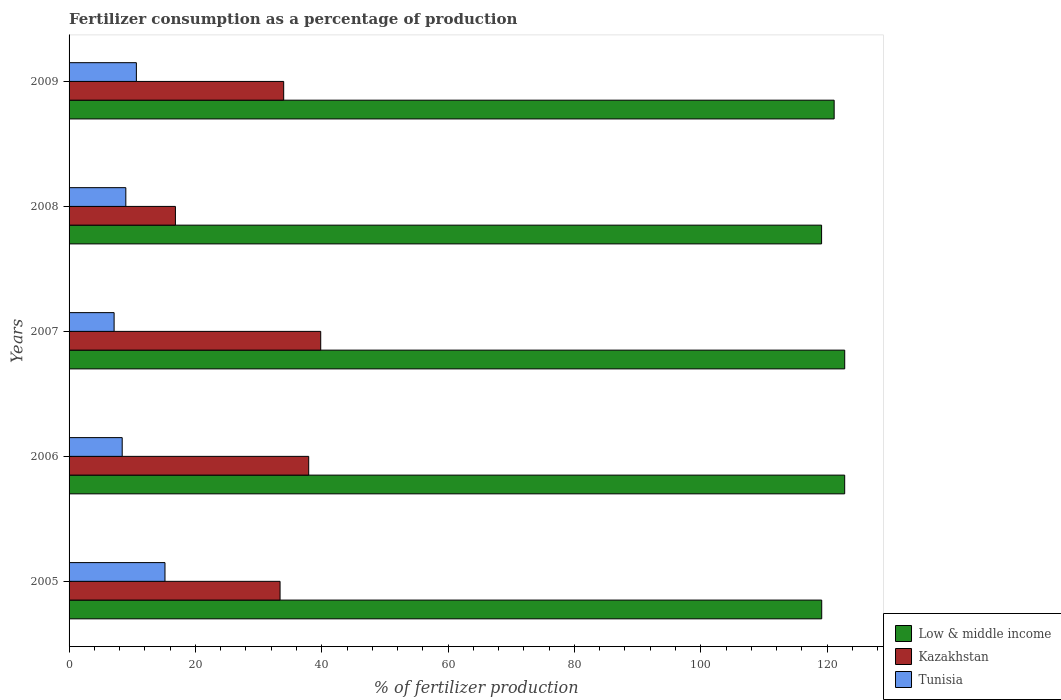How many groups of bars are there?
Provide a succinct answer. 5. Are the number of bars per tick equal to the number of legend labels?
Provide a short and direct response. Yes. Are the number of bars on each tick of the Y-axis equal?
Offer a terse response. Yes. What is the percentage of fertilizers consumed in Low & middle income in 2006?
Provide a short and direct response. 122.79. Across all years, what is the maximum percentage of fertilizers consumed in Tunisia?
Ensure brevity in your answer.  15.18. Across all years, what is the minimum percentage of fertilizers consumed in Kazakhstan?
Give a very brief answer. 16.84. In which year was the percentage of fertilizers consumed in Kazakhstan maximum?
Ensure brevity in your answer.  2007. What is the total percentage of fertilizers consumed in Low & middle income in the graph?
Your answer should be very brief. 604.98. What is the difference between the percentage of fertilizers consumed in Low & middle income in 2007 and that in 2009?
Provide a short and direct response. 1.67. What is the difference between the percentage of fertilizers consumed in Kazakhstan in 2006 and the percentage of fertilizers consumed in Low & middle income in 2009?
Offer a very short reply. -83.18. What is the average percentage of fertilizers consumed in Kazakhstan per year?
Give a very brief answer. 32.4. In the year 2007, what is the difference between the percentage of fertilizers consumed in Kazakhstan and percentage of fertilizers consumed in Low & middle income?
Keep it short and to the point. -82.95. What is the ratio of the percentage of fertilizers consumed in Tunisia in 2006 to that in 2008?
Give a very brief answer. 0.94. Is the percentage of fertilizers consumed in Low & middle income in 2005 less than that in 2008?
Your answer should be compact. No. Is the difference between the percentage of fertilizers consumed in Kazakhstan in 2005 and 2008 greater than the difference between the percentage of fertilizers consumed in Low & middle income in 2005 and 2008?
Offer a very short reply. Yes. What is the difference between the highest and the second highest percentage of fertilizers consumed in Kazakhstan?
Provide a succinct answer. 1.9. What is the difference between the highest and the lowest percentage of fertilizers consumed in Kazakhstan?
Give a very brief answer. 23. Is the sum of the percentage of fertilizers consumed in Kazakhstan in 2008 and 2009 greater than the maximum percentage of fertilizers consumed in Tunisia across all years?
Provide a short and direct response. Yes. What does the 3rd bar from the top in 2006 represents?
Provide a succinct answer. Low & middle income. What does the 1st bar from the bottom in 2006 represents?
Give a very brief answer. Low & middle income. How many bars are there?
Your response must be concise. 15. Are all the bars in the graph horizontal?
Ensure brevity in your answer.  Yes. How many years are there in the graph?
Your answer should be very brief. 5. What is the difference between two consecutive major ticks on the X-axis?
Offer a very short reply. 20. Are the values on the major ticks of X-axis written in scientific E-notation?
Offer a terse response. No. Does the graph contain any zero values?
Give a very brief answer. No. Does the graph contain grids?
Offer a terse response. No. How are the legend labels stacked?
Offer a terse response. Vertical. What is the title of the graph?
Your response must be concise. Fertilizer consumption as a percentage of production. Does "Antigua and Barbuda" appear as one of the legend labels in the graph?
Your answer should be compact. No. What is the label or title of the X-axis?
Ensure brevity in your answer.  % of fertilizer production. What is the % of fertilizer production in Low & middle income in 2005?
Offer a very short reply. 119.15. What is the % of fertilizer production in Kazakhstan in 2005?
Provide a succinct answer. 33.4. What is the % of fertilizer production in Tunisia in 2005?
Your answer should be compact. 15.18. What is the % of fertilizer production in Low & middle income in 2006?
Provide a short and direct response. 122.79. What is the % of fertilizer production in Kazakhstan in 2006?
Provide a short and direct response. 37.94. What is the % of fertilizer production of Tunisia in 2006?
Ensure brevity in your answer.  8.41. What is the % of fertilizer production in Low & middle income in 2007?
Give a very brief answer. 122.79. What is the % of fertilizer production in Kazakhstan in 2007?
Offer a terse response. 39.84. What is the % of fertilizer production in Tunisia in 2007?
Provide a short and direct response. 7.13. What is the % of fertilizer production in Low & middle income in 2008?
Offer a terse response. 119.13. What is the % of fertilizer production of Kazakhstan in 2008?
Give a very brief answer. 16.84. What is the % of fertilizer production in Tunisia in 2008?
Your answer should be very brief. 8.99. What is the % of fertilizer production of Low & middle income in 2009?
Provide a short and direct response. 121.12. What is the % of fertilizer production of Kazakhstan in 2009?
Offer a very short reply. 33.98. What is the % of fertilizer production in Tunisia in 2009?
Your response must be concise. 10.66. Across all years, what is the maximum % of fertilizer production of Low & middle income?
Offer a very short reply. 122.79. Across all years, what is the maximum % of fertilizer production in Kazakhstan?
Your answer should be very brief. 39.84. Across all years, what is the maximum % of fertilizer production of Tunisia?
Keep it short and to the point. 15.18. Across all years, what is the minimum % of fertilizer production of Low & middle income?
Keep it short and to the point. 119.13. Across all years, what is the minimum % of fertilizer production in Kazakhstan?
Ensure brevity in your answer.  16.84. Across all years, what is the minimum % of fertilizer production in Tunisia?
Provide a short and direct response. 7.13. What is the total % of fertilizer production in Low & middle income in the graph?
Give a very brief answer. 604.98. What is the total % of fertilizer production in Kazakhstan in the graph?
Your response must be concise. 161.99. What is the total % of fertilizer production of Tunisia in the graph?
Keep it short and to the point. 50.37. What is the difference between the % of fertilizer production of Low & middle income in 2005 and that in 2006?
Ensure brevity in your answer.  -3.64. What is the difference between the % of fertilizer production of Kazakhstan in 2005 and that in 2006?
Provide a short and direct response. -4.54. What is the difference between the % of fertilizer production in Tunisia in 2005 and that in 2006?
Make the answer very short. 6.77. What is the difference between the % of fertilizer production in Low & middle income in 2005 and that in 2007?
Offer a very short reply. -3.64. What is the difference between the % of fertilizer production of Kazakhstan in 2005 and that in 2007?
Ensure brevity in your answer.  -6.44. What is the difference between the % of fertilizer production in Tunisia in 2005 and that in 2007?
Provide a succinct answer. 8.05. What is the difference between the % of fertilizer production in Low & middle income in 2005 and that in 2008?
Your answer should be compact. 0.02. What is the difference between the % of fertilizer production in Kazakhstan in 2005 and that in 2008?
Provide a short and direct response. 16.56. What is the difference between the % of fertilizer production in Tunisia in 2005 and that in 2008?
Offer a terse response. 6.2. What is the difference between the % of fertilizer production in Low & middle income in 2005 and that in 2009?
Make the answer very short. -1.97. What is the difference between the % of fertilizer production in Kazakhstan in 2005 and that in 2009?
Give a very brief answer. -0.57. What is the difference between the % of fertilizer production of Tunisia in 2005 and that in 2009?
Offer a very short reply. 4.53. What is the difference between the % of fertilizer production in Low & middle income in 2006 and that in 2007?
Offer a very short reply. -0.01. What is the difference between the % of fertilizer production of Kazakhstan in 2006 and that in 2007?
Your answer should be very brief. -1.9. What is the difference between the % of fertilizer production in Tunisia in 2006 and that in 2007?
Make the answer very short. 1.28. What is the difference between the % of fertilizer production in Low & middle income in 2006 and that in 2008?
Your answer should be very brief. 3.66. What is the difference between the % of fertilizer production of Kazakhstan in 2006 and that in 2008?
Provide a short and direct response. 21.1. What is the difference between the % of fertilizer production of Tunisia in 2006 and that in 2008?
Give a very brief answer. -0.57. What is the difference between the % of fertilizer production in Low & middle income in 2006 and that in 2009?
Offer a very short reply. 1.67. What is the difference between the % of fertilizer production in Kazakhstan in 2006 and that in 2009?
Provide a succinct answer. 3.96. What is the difference between the % of fertilizer production of Tunisia in 2006 and that in 2009?
Give a very brief answer. -2.24. What is the difference between the % of fertilizer production in Low & middle income in 2007 and that in 2008?
Your answer should be compact. 3.66. What is the difference between the % of fertilizer production of Kazakhstan in 2007 and that in 2008?
Your answer should be very brief. 23. What is the difference between the % of fertilizer production of Tunisia in 2007 and that in 2008?
Your answer should be compact. -1.86. What is the difference between the % of fertilizer production in Low & middle income in 2007 and that in 2009?
Your answer should be very brief. 1.67. What is the difference between the % of fertilizer production of Kazakhstan in 2007 and that in 2009?
Your response must be concise. 5.86. What is the difference between the % of fertilizer production in Tunisia in 2007 and that in 2009?
Provide a succinct answer. -3.53. What is the difference between the % of fertilizer production of Low & middle income in 2008 and that in 2009?
Make the answer very short. -1.99. What is the difference between the % of fertilizer production in Kazakhstan in 2008 and that in 2009?
Provide a short and direct response. -17.14. What is the difference between the % of fertilizer production in Tunisia in 2008 and that in 2009?
Provide a short and direct response. -1.67. What is the difference between the % of fertilizer production in Low & middle income in 2005 and the % of fertilizer production in Kazakhstan in 2006?
Keep it short and to the point. 81.22. What is the difference between the % of fertilizer production of Low & middle income in 2005 and the % of fertilizer production of Tunisia in 2006?
Your answer should be compact. 110.74. What is the difference between the % of fertilizer production in Kazakhstan in 2005 and the % of fertilizer production in Tunisia in 2006?
Provide a succinct answer. 24.99. What is the difference between the % of fertilizer production in Low & middle income in 2005 and the % of fertilizer production in Kazakhstan in 2007?
Offer a very short reply. 79.31. What is the difference between the % of fertilizer production in Low & middle income in 2005 and the % of fertilizer production in Tunisia in 2007?
Keep it short and to the point. 112.02. What is the difference between the % of fertilizer production of Kazakhstan in 2005 and the % of fertilizer production of Tunisia in 2007?
Your answer should be compact. 26.27. What is the difference between the % of fertilizer production of Low & middle income in 2005 and the % of fertilizer production of Kazakhstan in 2008?
Give a very brief answer. 102.31. What is the difference between the % of fertilizer production of Low & middle income in 2005 and the % of fertilizer production of Tunisia in 2008?
Give a very brief answer. 110.17. What is the difference between the % of fertilizer production of Kazakhstan in 2005 and the % of fertilizer production of Tunisia in 2008?
Offer a terse response. 24.42. What is the difference between the % of fertilizer production in Low & middle income in 2005 and the % of fertilizer production in Kazakhstan in 2009?
Your answer should be very brief. 85.18. What is the difference between the % of fertilizer production in Low & middle income in 2005 and the % of fertilizer production in Tunisia in 2009?
Ensure brevity in your answer.  108.5. What is the difference between the % of fertilizer production of Kazakhstan in 2005 and the % of fertilizer production of Tunisia in 2009?
Offer a very short reply. 22.75. What is the difference between the % of fertilizer production in Low & middle income in 2006 and the % of fertilizer production in Kazakhstan in 2007?
Offer a very short reply. 82.95. What is the difference between the % of fertilizer production of Low & middle income in 2006 and the % of fertilizer production of Tunisia in 2007?
Keep it short and to the point. 115.66. What is the difference between the % of fertilizer production in Kazakhstan in 2006 and the % of fertilizer production in Tunisia in 2007?
Make the answer very short. 30.81. What is the difference between the % of fertilizer production of Low & middle income in 2006 and the % of fertilizer production of Kazakhstan in 2008?
Your answer should be very brief. 105.95. What is the difference between the % of fertilizer production in Low & middle income in 2006 and the % of fertilizer production in Tunisia in 2008?
Provide a succinct answer. 113.8. What is the difference between the % of fertilizer production in Kazakhstan in 2006 and the % of fertilizer production in Tunisia in 2008?
Give a very brief answer. 28.95. What is the difference between the % of fertilizer production of Low & middle income in 2006 and the % of fertilizer production of Kazakhstan in 2009?
Your answer should be very brief. 88.81. What is the difference between the % of fertilizer production in Low & middle income in 2006 and the % of fertilizer production in Tunisia in 2009?
Keep it short and to the point. 112.13. What is the difference between the % of fertilizer production of Kazakhstan in 2006 and the % of fertilizer production of Tunisia in 2009?
Offer a terse response. 27.28. What is the difference between the % of fertilizer production of Low & middle income in 2007 and the % of fertilizer production of Kazakhstan in 2008?
Give a very brief answer. 105.96. What is the difference between the % of fertilizer production in Low & middle income in 2007 and the % of fertilizer production in Tunisia in 2008?
Keep it short and to the point. 113.81. What is the difference between the % of fertilizer production of Kazakhstan in 2007 and the % of fertilizer production of Tunisia in 2008?
Give a very brief answer. 30.85. What is the difference between the % of fertilizer production in Low & middle income in 2007 and the % of fertilizer production in Kazakhstan in 2009?
Ensure brevity in your answer.  88.82. What is the difference between the % of fertilizer production in Low & middle income in 2007 and the % of fertilizer production in Tunisia in 2009?
Provide a succinct answer. 112.14. What is the difference between the % of fertilizer production of Kazakhstan in 2007 and the % of fertilizer production of Tunisia in 2009?
Keep it short and to the point. 29.18. What is the difference between the % of fertilizer production in Low & middle income in 2008 and the % of fertilizer production in Kazakhstan in 2009?
Make the answer very short. 85.16. What is the difference between the % of fertilizer production of Low & middle income in 2008 and the % of fertilizer production of Tunisia in 2009?
Your answer should be compact. 108.48. What is the difference between the % of fertilizer production in Kazakhstan in 2008 and the % of fertilizer production in Tunisia in 2009?
Provide a short and direct response. 6.18. What is the average % of fertilizer production in Low & middle income per year?
Your answer should be compact. 121. What is the average % of fertilizer production in Kazakhstan per year?
Make the answer very short. 32.4. What is the average % of fertilizer production of Tunisia per year?
Make the answer very short. 10.07. In the year 2005, what is the difference between the % of fertilizer production of Low & middle income and % of fertilizer production of Kazakhstan?
Make the answer very short. 85.75. In the year 2005, what is the difference between the % of fertilizer production of Low & middle income and % of fertilizer production of Tunisia?
Your response must be concise. 103.97. In the year 2005, what is the difference between the % of fertilizer production of Kazakhstan and % of fertilizer production of Tunisia?
Offer a very short reply. 18.22. In the year 2006, what is the difference between the % of fertilizer production of Low & middle income and % of fertilizer production of Kazakhstan?
Your answer should be very brief. 84.85. In the year 2006, what is the difference between the % of fertilizer production of Low & middle income and % of fertilizer production of Tunisia?
Provide a succinct answer. 114.38. In the year 2006, what is the difference between the % of fertilizer production of Kazakhstan and % of fertilizer production of Tunisia?
Your response must be concise. 29.52. In the year 2007, what is the difference between the % of fertilizer production in Low & middle income and % of fertilizer production in Kazakhstan?
Provide a succinct answer. 82.95. In the year 2007, what is the difference between the % of fertilizer production in Low & middle income and % of fertilizer production in Tunisia?
Give a very brief answer. 115.66. In the year 2007, what is the difference between the % of fertilizer production in Kazakhstan and % of fertilizer production in Tunisia?
Ensure brevity in your answer.  32.71. In the year 2008, what is the difference between the % of fertilizer production of Low & middle income and % of fertilizer production of Kazakhstan?
Make the answer very short. 102.29. In the year 2008, what is the difference between the % of fertilizer production of Low & middle income and % of fertilizer production of Tunisia?
Offer a terse response. 110.15. In the year 2008, what is the difference between the % of fertilizer production of Kazakhstan and % of fertilizer production of Tunisia?
Provide a short and direct response. 7.85. In the year 2009, what is the difference between the % of fertilizer production of Low & middle income and % of fertilizer production of Kazakhstan?
Your response must be concise. 87.14. In the year 2009, what is the difference between the % of fertilizer production of Low & middle income and % of fertilizer production of Tunisia?
Make the answer very short. 110.46. In the year 2009, what is the difference between the % of fertilizer production in Kazakhstan and % of fertilizer production in Tunisia?
Your response must be concise. 23.32. What is the ratio of the % of fertilizer production in Low & middle income in 2005 to that in 2006?
Make the answer very short. 0.97. What is the ratio of the % of fertilizer production of Kazakhstan in 2005 to that in 2006?
Offer a terse response. 0.88. What is the ratio of the % of fertilizer production in Tunisia in 2005 to that in 2006?
Provide a succinct answer. 1.8. What is the ratio of the % of fertilizer production in Low & middle income in 2005 to that in 2007?
Give a very brief answer. 0.97. What is the ratio of the % of fertilizer production in Kazakhstan in 2005 to that in 2007?
Your response must be concise. 0.84. What is the ratio of the % of fertilizer production in Tunisia in 2005 to that in 2007?
Offer a very short reply. 2.13. What is the ratio of the % of fertilizer production in Kazakhstan in 2005 to that in 2008?
Provide a short and direct response. 1.98. What is the ratio of the % of fertilizer production of Tunisia in 2005 to that in 2008?
Offer a terse response. 1.69. What is the ratio of the % of fertilizer production of Low & middle income in 2005 to that in 2009?
Offer a very short reply. 0.98. What is the ratio of the % of fertilizer production of Kazakhstan in 2005 to that in 2009?
Provide a succinct answer. 0.98. What is the ratio of the % of fertilizer production in Tunisia in 2005 to that in 2009?
Provide a short and direct response. 1.42. What is the ratio of the % of fertilizer production in Kazakhstan in 2006 to that in 2007?
Ensure brevity in your answer.  0.95. What is the ratio of the % of fertilizer production in Tunisia in 2006 to that in 2007?
Offer a terse response. 1.18. What is the ratio of the % of fertilizer production in Low & middle income in 2006 to that in 2008?
Your response must be concise. 1.03. What is the ratio of the % of fertilizer production in Kazakhstan in 2006 to that in 2008?
Provide a succinct answer. 2.25. What is the ratio of the % of fertilizer production in Tunisia in 2006 to that in 2008?
Ensure brevity in your answer.  0.94. What is the ratio of the % of fertilizer production of Low & middle income in 2006 to that in 2009?
Offer a terse response. 1.01. What is the ratio of the % of fertilizer production of Kazakhstan in 2006 to that in 2009?
Your answer should be compact. 1.12. What is the ratio of the % of fertilizer production in Tunisia in 2006 to that in 2009?
Make the answer very short. 0.79. What is the ratio of the % of fertilizer production of Low & middle income in 2007 to that in 2008?
Make the answer very short. 1.03. What is the ratio of the % of fertilizer production of Kazakhstan in 2007 to that in 2008?
Make the answer very short. 2.37. What is the ratio of the % of fertilizer production in Tunisia in 2007 to that in 2008?
Keep it short and to the point. 0.79. What is the ratio of the % of fertilizer production in Low & middle income in 2007 to that in 2009?
Offer a terse response. 1.01. What is the ratio of the % of fertilizer production of Kazakhstan in 2007 to that in 2009?
Offer a very short reply. 1.17. What is the ratio of the % of fertilizer production of Tunisia in 2007 to that in 2009?
Your response must be concise. 0.67. What is the ratio of the % of fertilizer production in Low & middle income in 2008 to that in 2009?
Your answer should be very brief. 0.98. What is the ratio of the % of fertilizer production in Kazakhstan in 2008 to that in 2009?
Provide a succinct answer. 0.5. What is the ratio of the % of fertilizer production of Tunisia in 2008 to that in 2009?
Provide a short and direct response. 0.84. What is the difference between the highest and the second highest % of fertilizer production in Low & middle income?
Offer a very short reply. 0.01. What is the difference between the highest and the second highest % of fertilizer production of Kazakhstan?
Make the answer very short. 1.9. What is the difference between the highest and the second highest % of fertilizer production in Tunisia?
Your response must be concise. 4.53. What is the difference between the highest and the lowest % of fertilizer production of Low & middle income?
Your response must be concise. 3.66. What is the difference between the highest and the lowest % of fertilizer production in Kazakhstan?
Give a very brief answer. 23. What is the difference between the highest and the lowest % of fertilizer production in Tunisia?
Give a very brief answer. 8.05. 